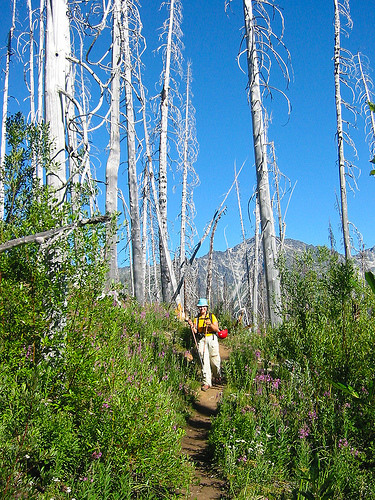<image>
Is the plant behind the woman? No. The plant is not behind the woman. From this viewpoint, the plant appears to be positioned elsewhere in the scene. 